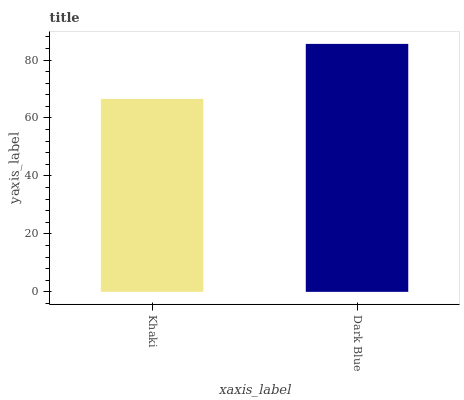Is Khaki the minimum?
Answer yes or no. Yes. Is Dark Blue the maximum?
Answer yes or no. Yes. Is Dark Blue the minimum?
Answer yes or no. No. Is Dark Blue greater than Khaki?
Answer yes or no. Yes. Is Khaki less than Dark Blue?
Answer yes or no. Yes. Is Khaki greater than Dark Blue?
Answer yes or no. No. Is Dark Blue less than Khaki?
Answer yes or no. No. Is Dark Blue the high median?
Answer yes or no. Yes. Is Khaki the low median?
Answer yes or no. Yes. Is Khaki the high median?
Answer yes or no. No. Is Dark Blue the low median?
Answer yes or no. No. 